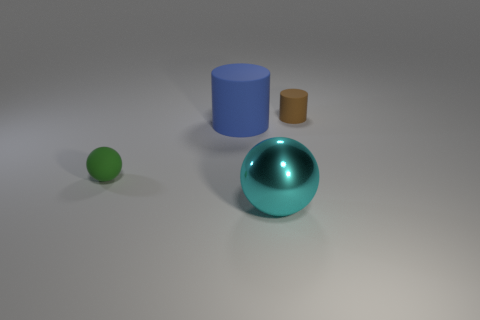Is the material of the cyan sphere the same as the blue thing?
Your answer should be very brief. No. There is a cyan sphere that is the same size as the blue object; what material is it?
Make the answer very short. Metal. Is the material of the large object right of the big matte object the same as the large thing that is behind the metallic sphere?
Provide a succinct answer. No. There is a green ball that is left of the brown cylinder that is behind the large metallic ball; how big is it?
Your response must be concise. Small. What material is the cylinder that is to the left of the small brown rubber cylinder?
Your response must be concise. Rubber. What number of objects are objects that are on the left side of the cyan thing or matte cylinders right of the big sphere?
Your answer should be very brief. 3. What is the material of the other tiny thing that is the same shape as the blue thing?
Make the answer very short. Rubber. Is there a sphere of the same size as the brown thing?
Your answer should be compact. Yes. The thing that is to the right of the small sphere and on the left side of the cyan shiny sphere is made of what material?
Your answer should be very brief. Rubber. What number of matte objects are either tiny purple objects or large cyan objects?
Offer a very short reply. 0. 